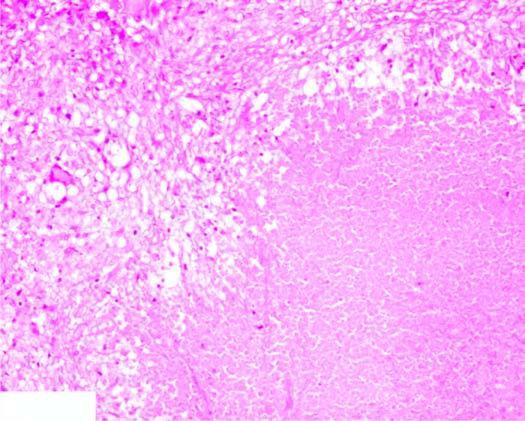does the periphery show granulomatous inflammation?
Answer the question using a single word or phrase. Yes 